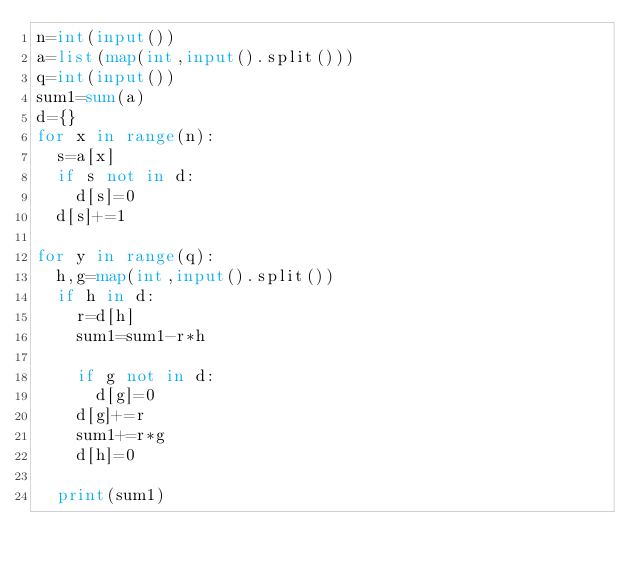<code> <loc_0><loc_0><loc_500><loc_500><_Python_>n=int(input())
a=list(map(int,input().split()))
q=int(input())
sum1=sum(a)
d={}
for x in range(n):
  s=a[x]
  if s not in d:
    d[s]=0
  d[s]+=1

for y in range(q):
  h,g=map(int,input().split())
  if h in d:
    r=d[h]
    sum1=sum1-r*h
    
    if g not in d:
      d[g]=0
    d[g]+=r
    sum1+=r*g
    d[h]=0
    
  print(sum1)</code> 